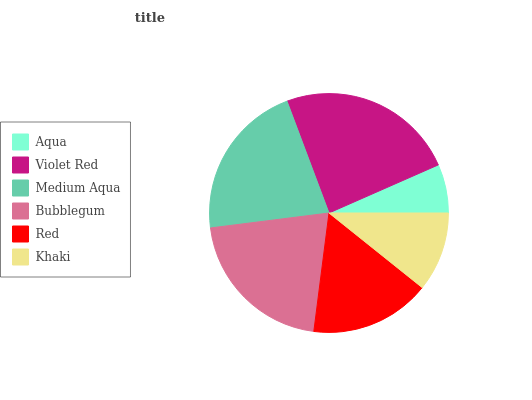Is Aqua the minimum?
Answer yes or no. Yes. Is Violet Red the maximum?
Answer yes or no. Yes. Is Medium Aqua the minimum?
Answer yes or no. No. Is Medium Aqua the maximum?
Answer yes or no. No. Is Violet Red greater than Medium Aqua?
Answer yes or no. Yes. Is Medium Aqua less than Violet Red?
Answer yes or no. Yes. Is Medium Aqua greater than Violet Red?
Answer yes or no. No. Is Violet Red less than Medium Aqua?
Answer yes or no. No. Is Bubblegum the high median?
Answer yes or no. Yes. Is Red the low median?
Answer yes or no. Yes. Is Violet Red the high median?
Answer yes or no. No. Is Khaki the low median?
Answer yes or no. No. 